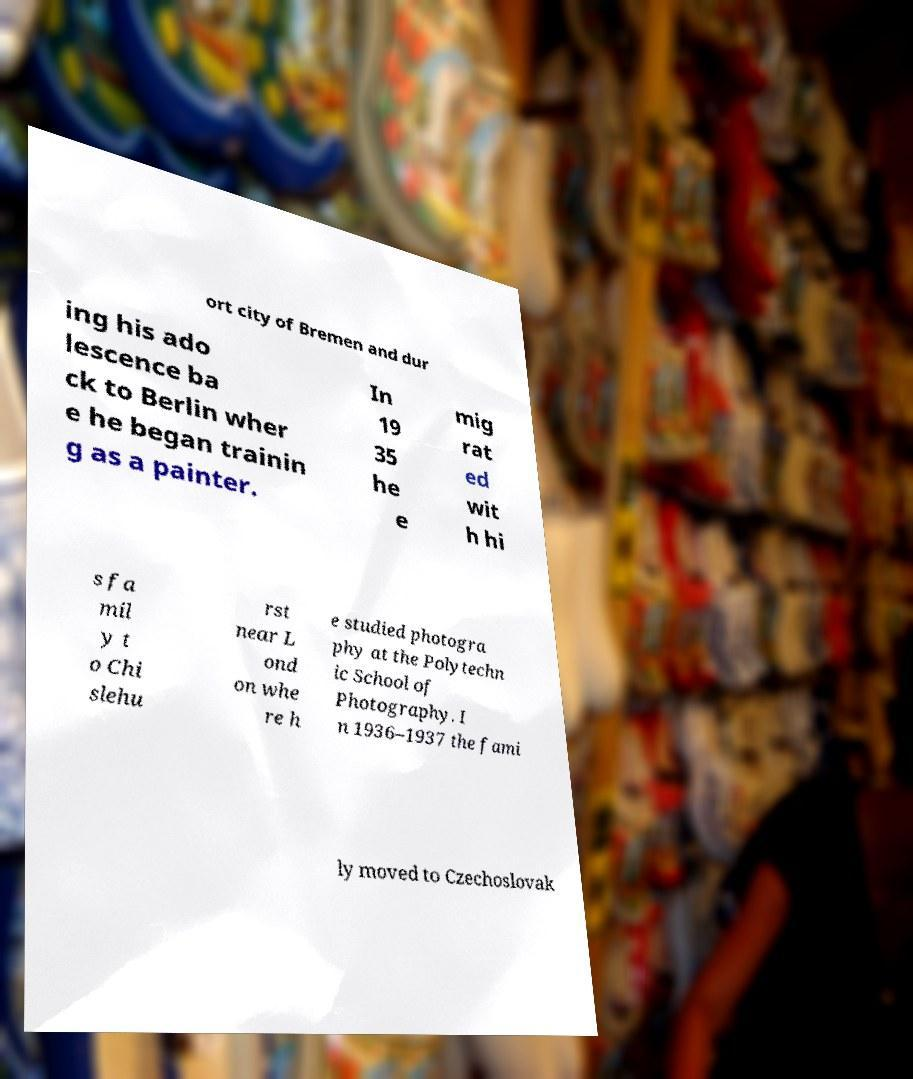Can you accurately transcribe the text from the provided image for me? ort city of Bremen and dur ing his ado lescence ba ck to Berlin wher e he began trainin g as a painter. In 19 35 he e mig rat ed wit h hi s fa mil y t o Chi slehu rst near L ond on whe re h e studied photogra phy at the Polytechn ic School of Photography. I n 1936–1937 the fami ly moved to Czechoslovak 